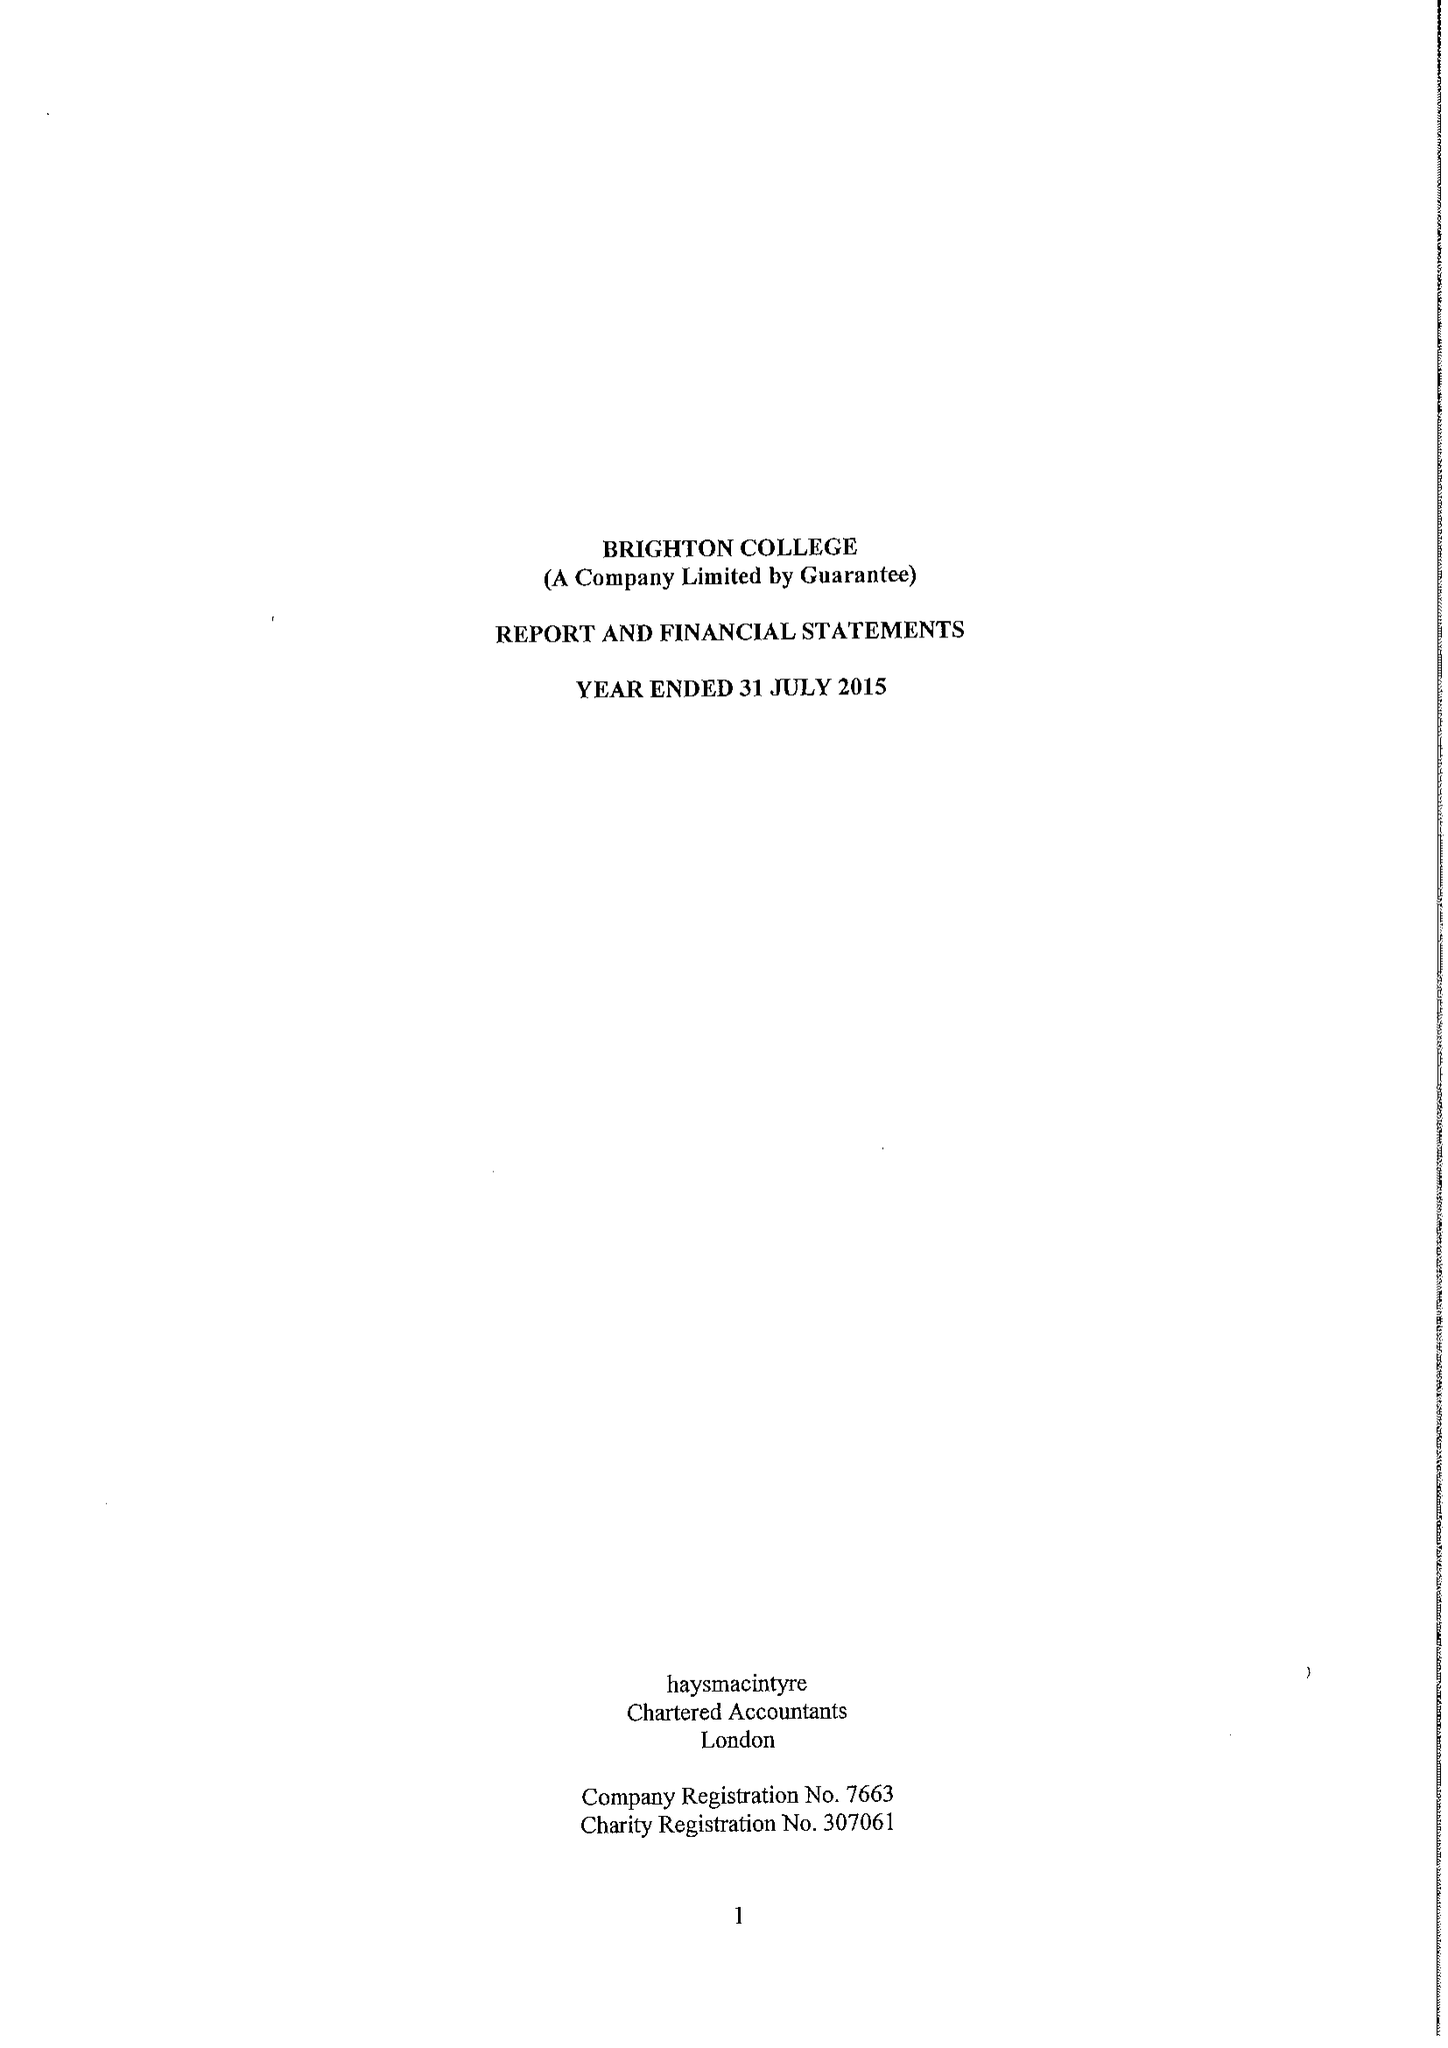What is the value for the charity_number?
Answer the question using a single word or phrase. 307061 